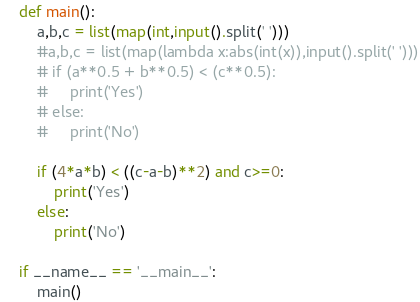<code> <loc_0><loc_0><loc_500><loc_500><_Python_>def main():
    a,b,c = list(map(int,input().split(' ')))
    #a,b,c = list(map(lambda x:abs(int(x)),input().split(' ')))
    # if (a**0.5 + b**0.5) < (c**0.5):
    #     print('Yes')
    # else:
    #     print('No')

    if (4*a*b) < ((c-a-b)**2) and c>=0:
        print('Yes')
    else:
        print('No')

if __name__ == '__main__':
    main()
</code> 